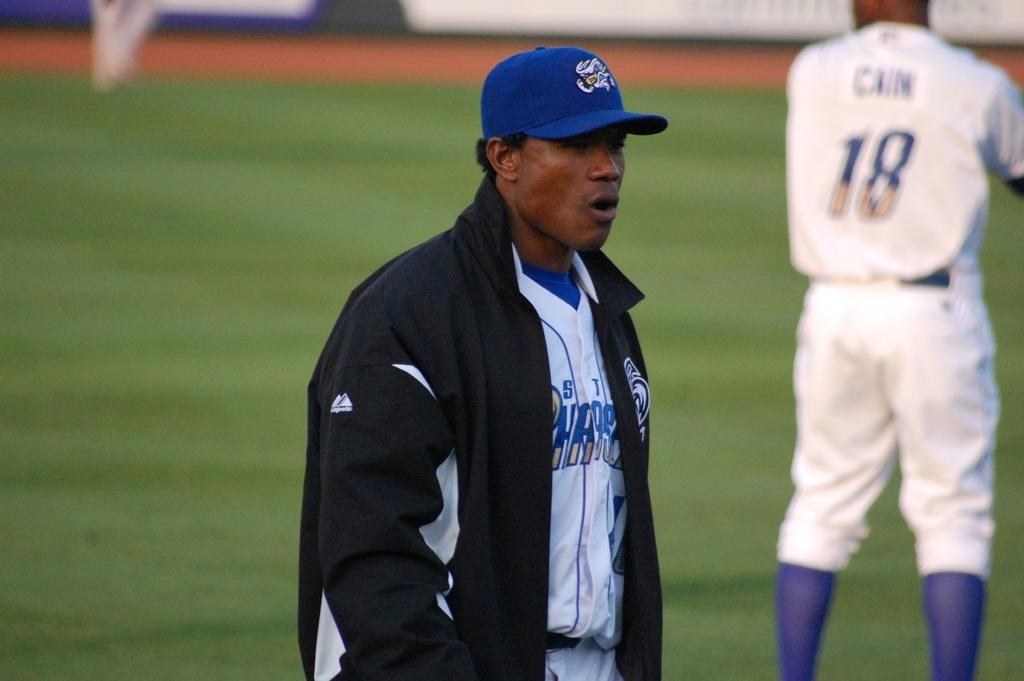What is the name on the back of number 18's jersey?
Provide a succinct answer. Cain. 